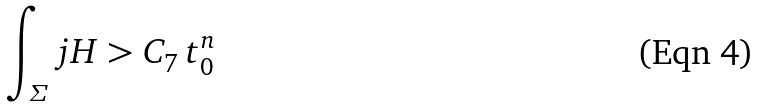<formula> <loc_0><loc_0><loc_500><loc_500>\int _ { \varSigma } j H > C _ { 7 } \, t _ { 0 } ^ { n }</formula> 